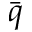Convert formula to latex. <formula><loc_0><loc_0><loc_500><loc_500>\ B a r { q }</formula> 